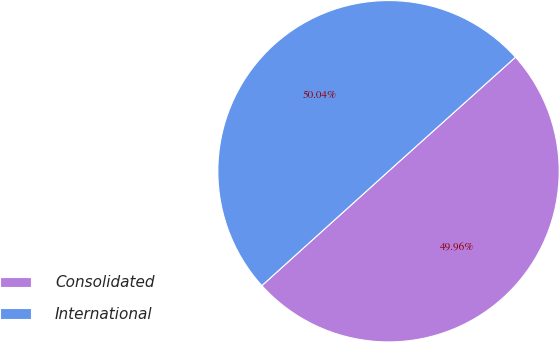Convert chart to OTSL. <chart><loc_0><loc_0><loc_500><loc_500><pie_chart><fcel>Consolidated<fcel>International<nl><fcel>49.96%<fcel>50.04%<nl></chart> 